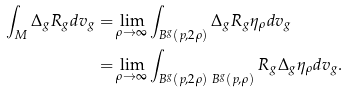Convert formula to latex. <formula><loc_0><loc_0><loc_500><loc_500>\int _ { M } \Delta _ { g } R _ { g } d v _ { g } = & \lim _ { \rho \rightarrow \infty } \int _ { B ^ { g } ( p , 2 \rho ) } \Delta _ { g } R _ { g } \eta _ { \rho } d v _ { g } \\ = & \lim _ { \rho \rightarrow \infty } \int _ { B ^ { g } ( p , 2 \rho ) \ B ^ { g } ( p , \rho ) } R _ { g } \Delta _ { g } \eta _ { \rho } d v _ { g } . \\</formula> 